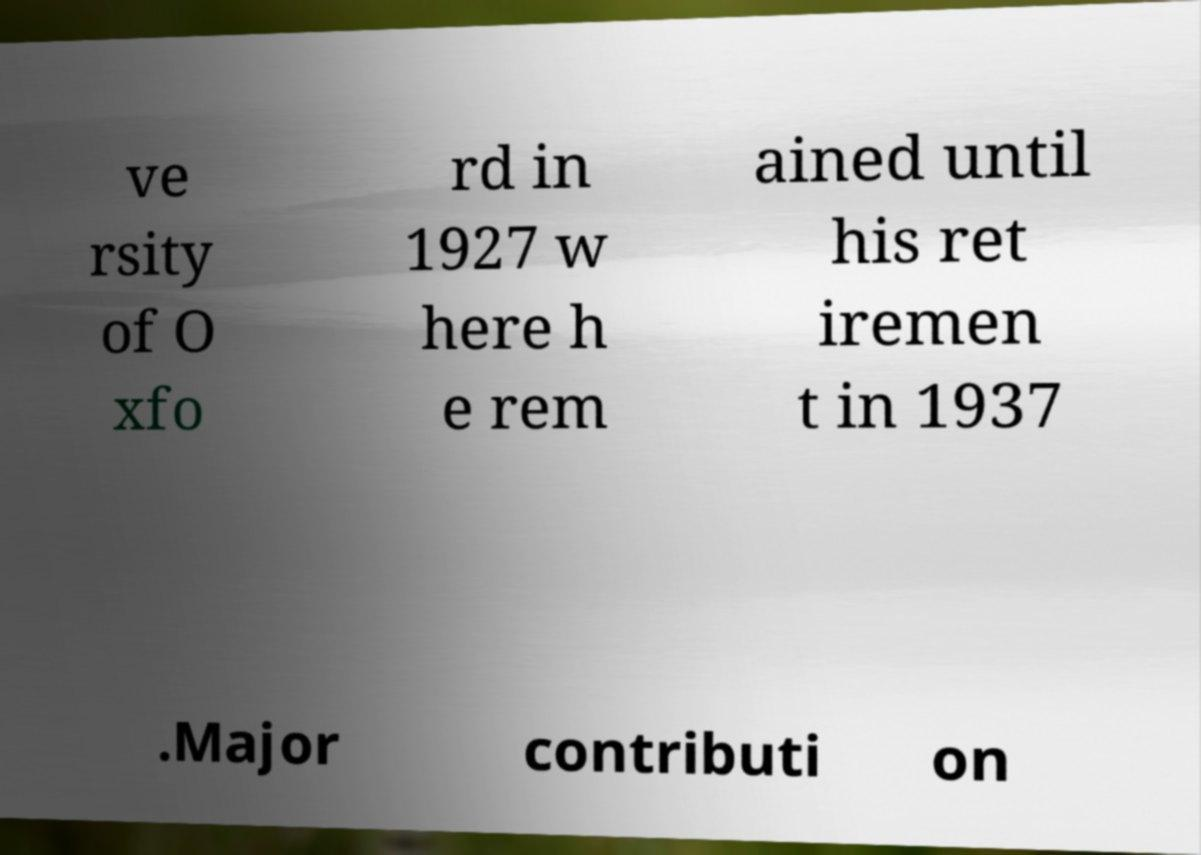There's text embedded in this image that I need extracted. Can you transcribe it verbatim? ve rsity of O xfo rd in 1927 w here h e rem ained until his ret iremen t in 1937 .Major contributi on 